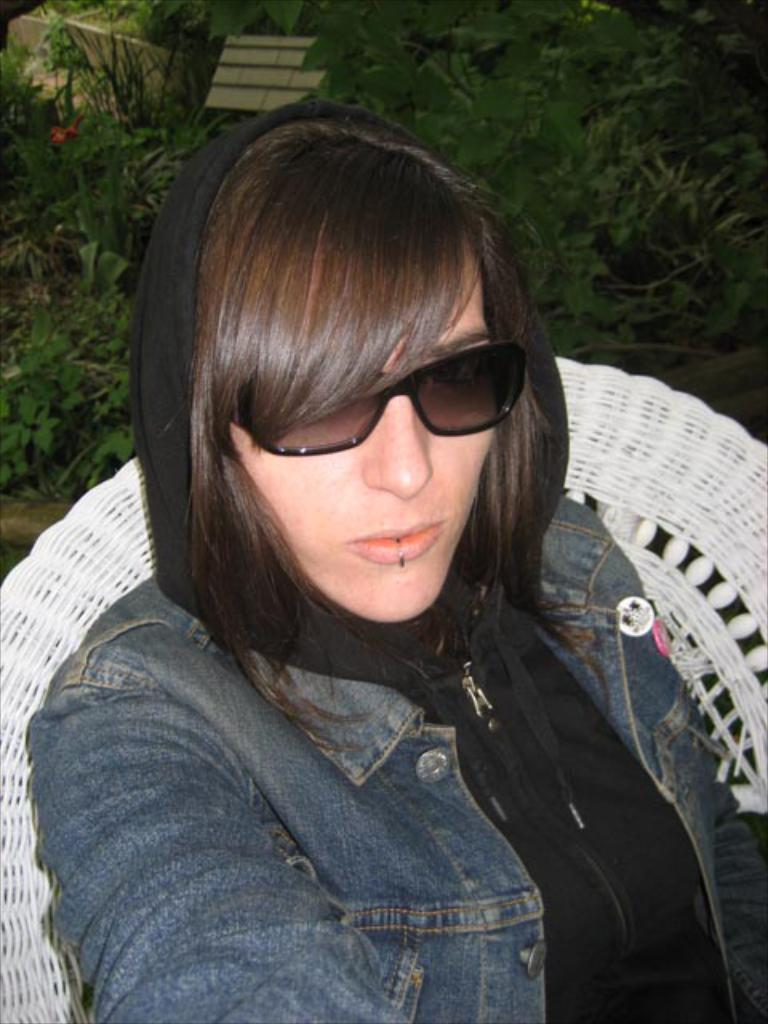Who or what is present in the image? There is a person in the image. What is the person wearing? The person is wearing goggles. What can be seen in the background of the image? There are plants and objects in the background of the image. What advice does the person give to the loaf in the image? There is no loaf present in the image, and therefore no advice can be given. 